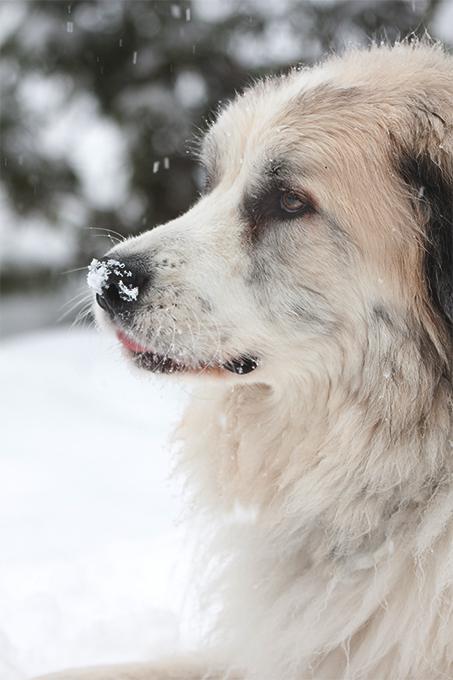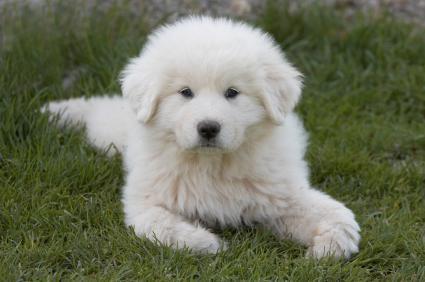The first image is the image on the left, the second image is the image on the right. Evaluate the accuracy of this statement regarding the images: "The dog on the right image is of a young puppy.". Is it true? Answer yes or no. Yes. 